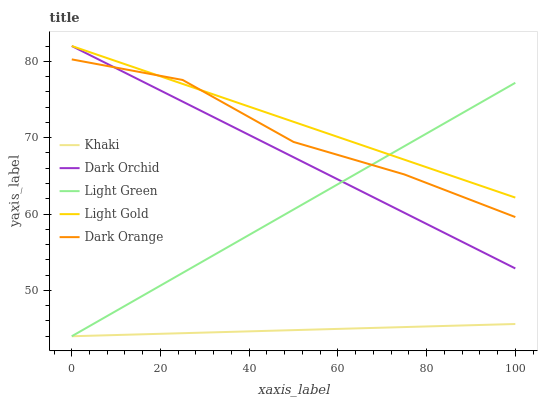Does Khaki have the minimum area under the curve?
Answer yes or no. Yes. Does Light Gold have the maximum area under the curve?
Answer yes or no. Yes. Does Light Gold have the minimum area under the curve?
Answer yes or no. No. Does Khaki have the maximum area under the curve?
Answer yes or no. No. Is Light Green the smoothest?
Answer yes or no. Yes. Is Dark Orange the roughest?
Answer yes or no. Yes. Is Khaki the smoothest?
Answer yes or no. No. Is Khaki the roughest?
Answer yes or no. No. Does Khaki have the lowest value?
Answer yes or no. Yes. Does Light Gold have the lowest value?
Answer yes or no. No. Does Dark Orchid have the highest value?
Answer yes or no. Yes. Does Khaki have the highest value?
Answer yes or no. No. Is Khaki less than Dark Orange?
Answer yes or no. Yes. Is Dark Orchid greater than Khaki?
Answer yes or no. Yes. Does Dark Orchid intersect Dark Orange?
Answer yes or no. Yes. Is Dark Orchid less than Dark Orange?
Answer yes or no. No. Is Dark Orchid greater than Dark Orange?
Answer yes or no. No. Does Khaki intersect Dark Orange?
Answer yes or no. No. 